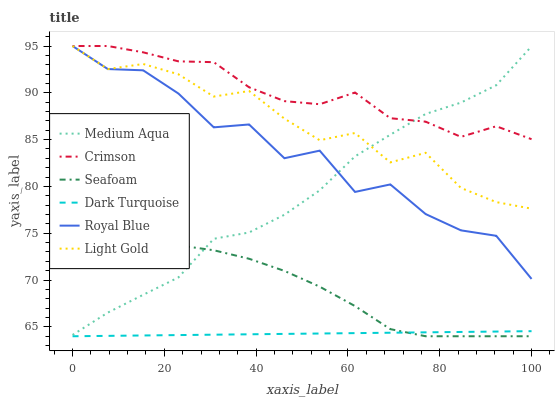Does Dark Turquoise have the minimum area under the curve?
Answer yes or no. Yes. Does Crimson have the maximum area under the curve?
Answer yes or no. Yes. Does Seafoam have the minimum area under the curve?
Answer yes or no. No. Does Seafoam have the maximum area under the curve?
Answer yes or no. No. Is Dark Turquoise the smoothest?
Answer yes or no. Yes. Is Royal Blue the roughest?
Answer yes or no. Yes. Is Seafoam the smoothest?
Answer yes or no. No. Is Seafoam the roughest?
Answer yes or no. No. Does Dark Turquoise have the lowest value?
Answer yes or no. Yes. Does Royal Blue have the lowest value?
Answer yes or no. No. Does Light Gold have the highest value?
Answer yes or no. Yes. Does Seafoam have the highest value?
Answer yes or no. No. Is Dark Turquoise less than Medium Aqua?
Answer yes or no. Yes. Is Crimson greater than Seafoam?
Answer yes or no. Yes. Does Medium Aqua intersect Light Gold?
Answer yes or no. Yes. Is Medium Aqua less than Light Gold?
Answer yes or no. No. Is Medium Aqua greater than Light Gold?
Answer yes or no. No. Does Dark Turquoise intersect Medium Aqua?
Answer yes or no. No. 